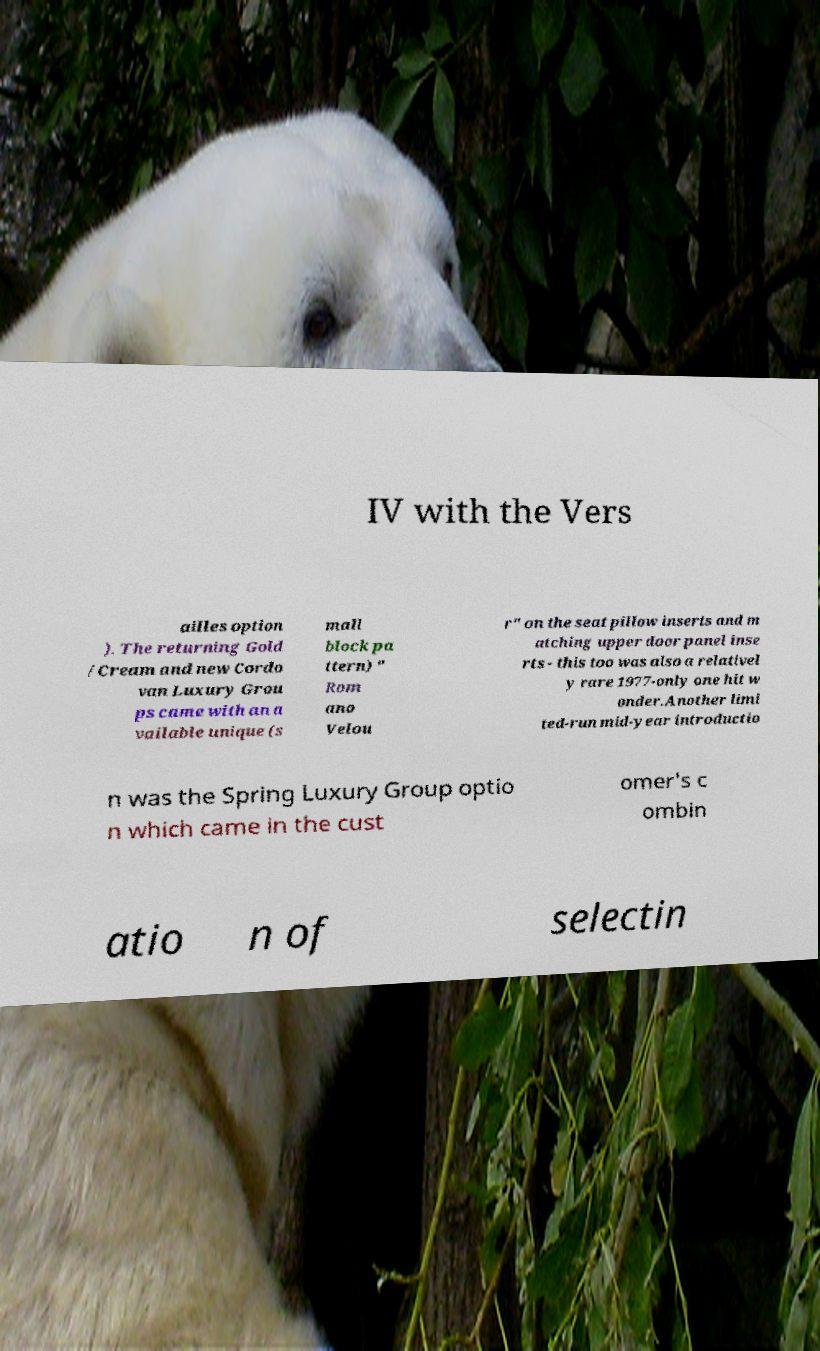Please read and relay the text visible in this image. What does it say? IV with the Vers ailles option ). The returning Gold /Cream and new Cordo van Luxury Grou ps came with an a vailable unique (s mall block pa ttern) " Rom ano Velou r" on the seat pillow inserts and m atching upper door panel inse rts - this too was also a relativel y rare 1977-only one hit w onder.Another limi ted-run mid-year introductio n was the Spring Luxury Group optio n which came in the cust omer's c ombin atio n of selectin 